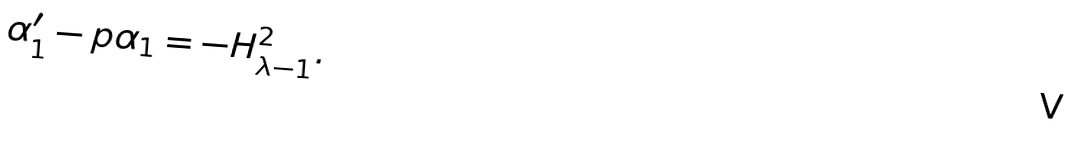<formula> <loc_0><loc_0><loc_500><loc_500>\alpha _ { 1 } ^ { \prime } - p \alpha _ { 1 } = - H _ { \lambda - 1 } ^ { 2 } .</formula> 